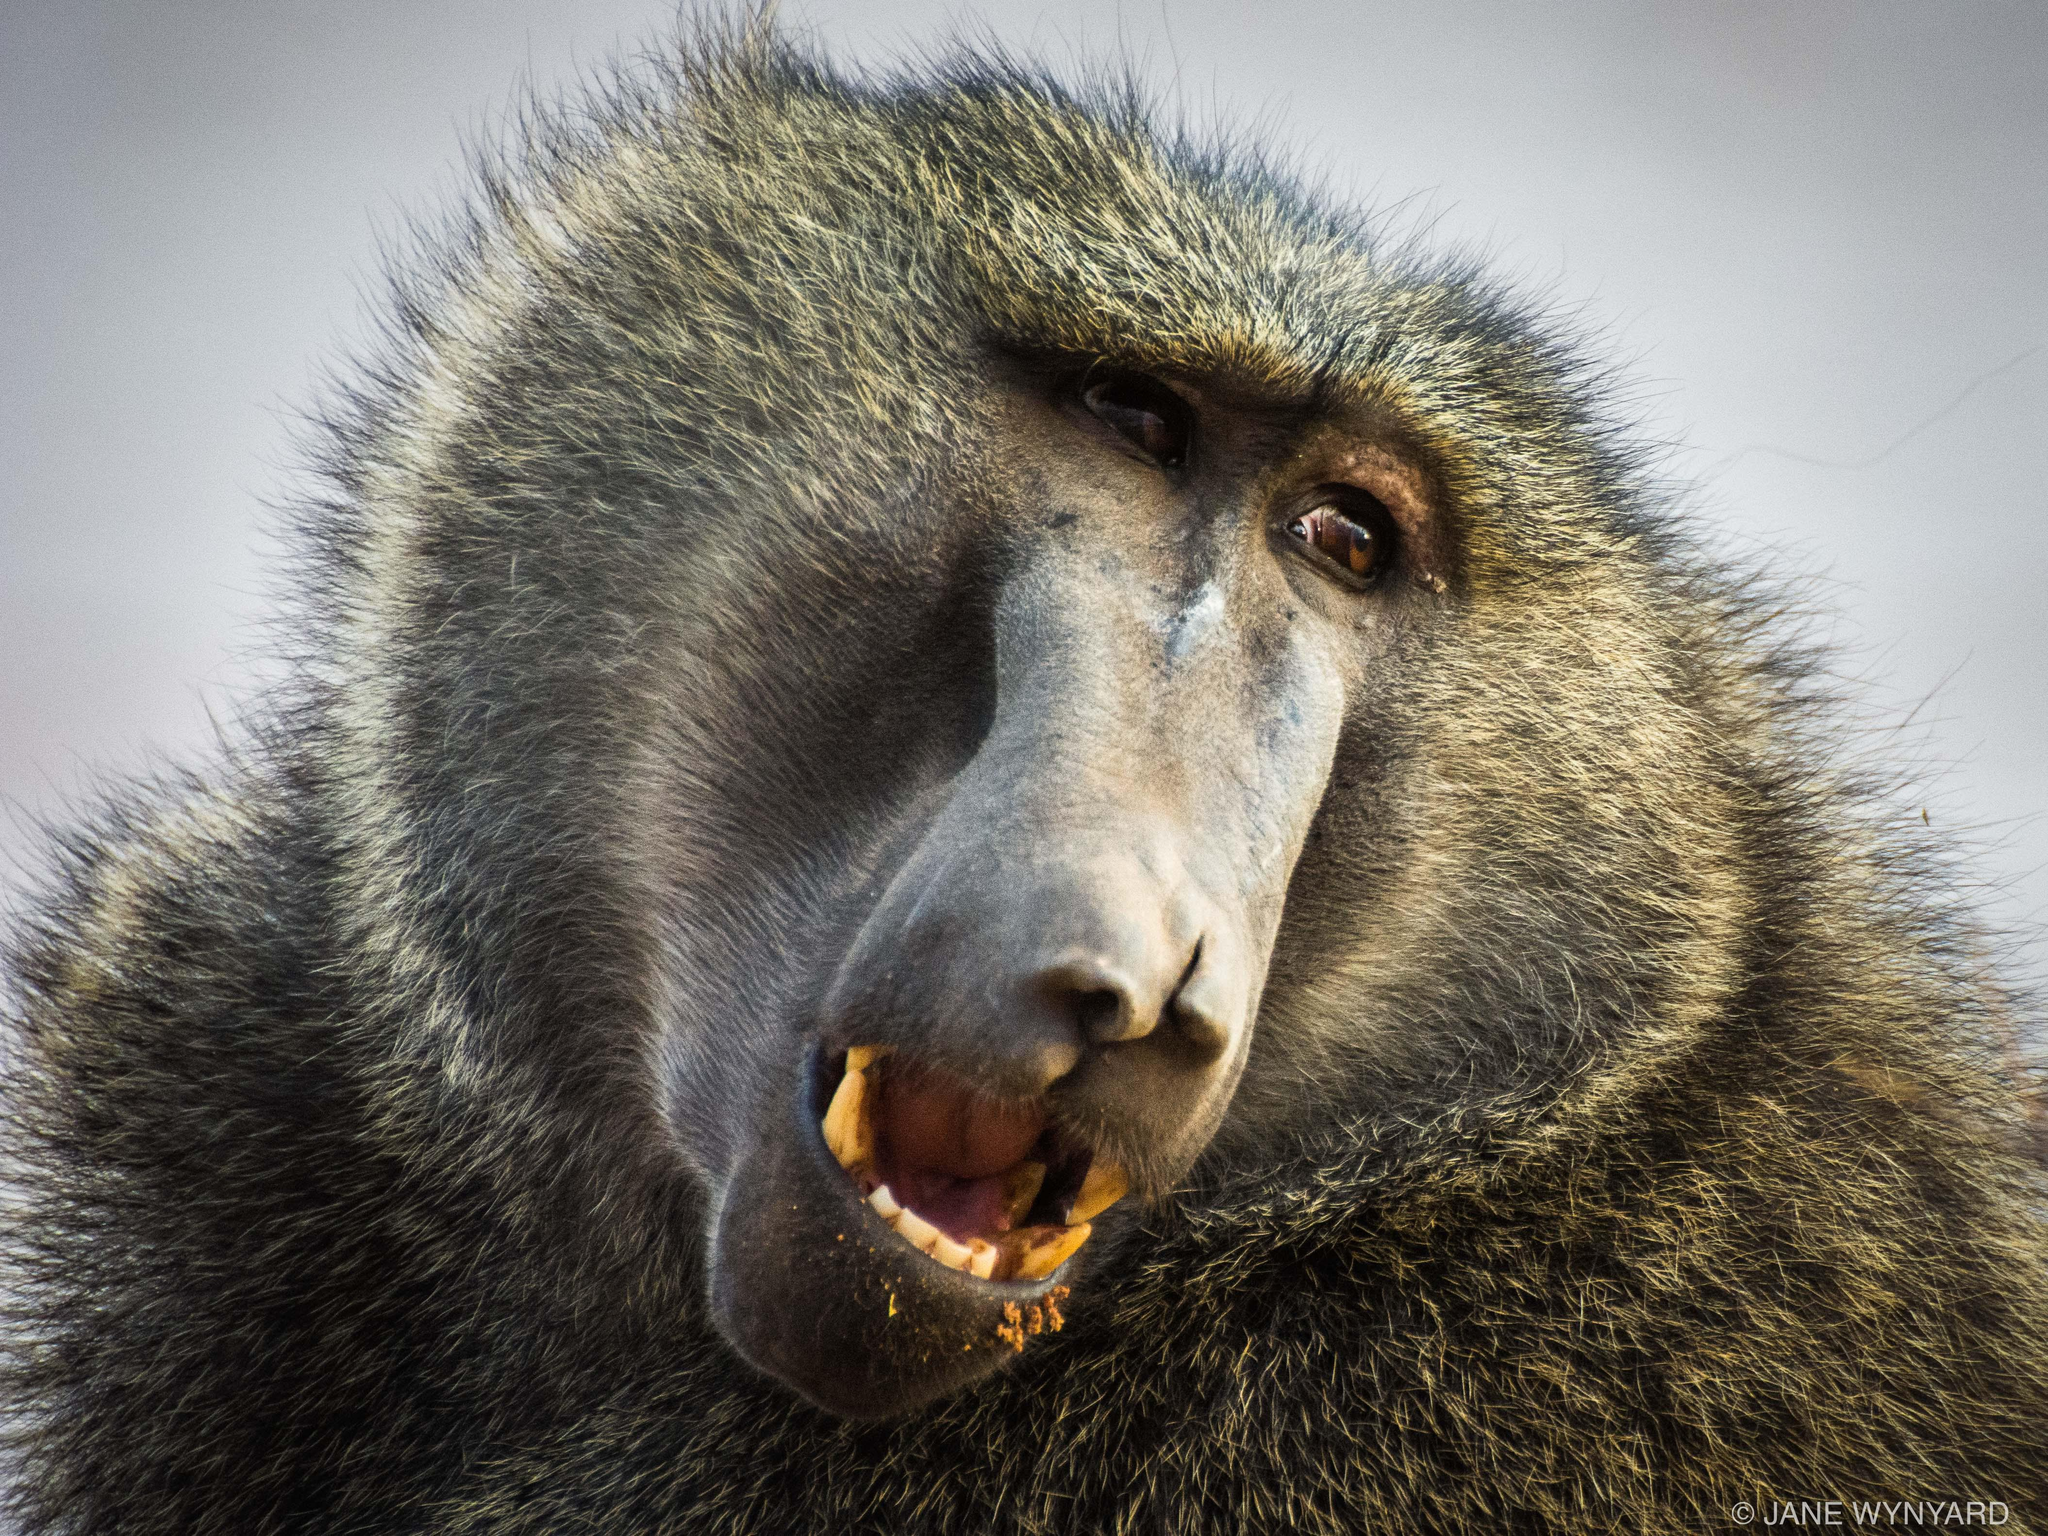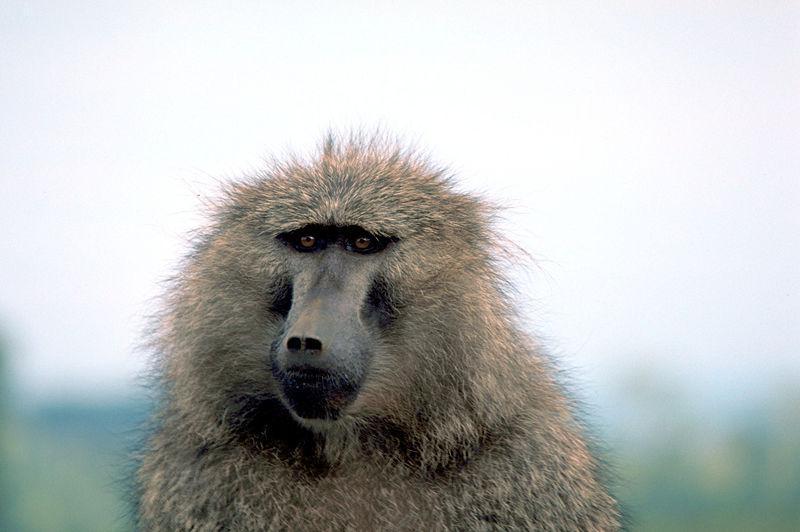The first image is the image on the left, the second image is the image on the right. Examine the images to the left and right. Is the description "One monkey is showing its teeth" accurate? Answer yes or no. Yes. 